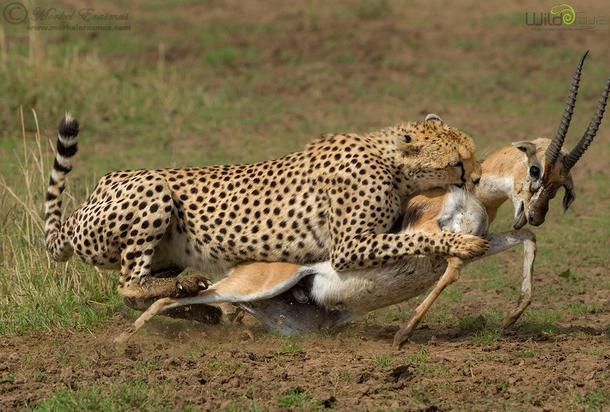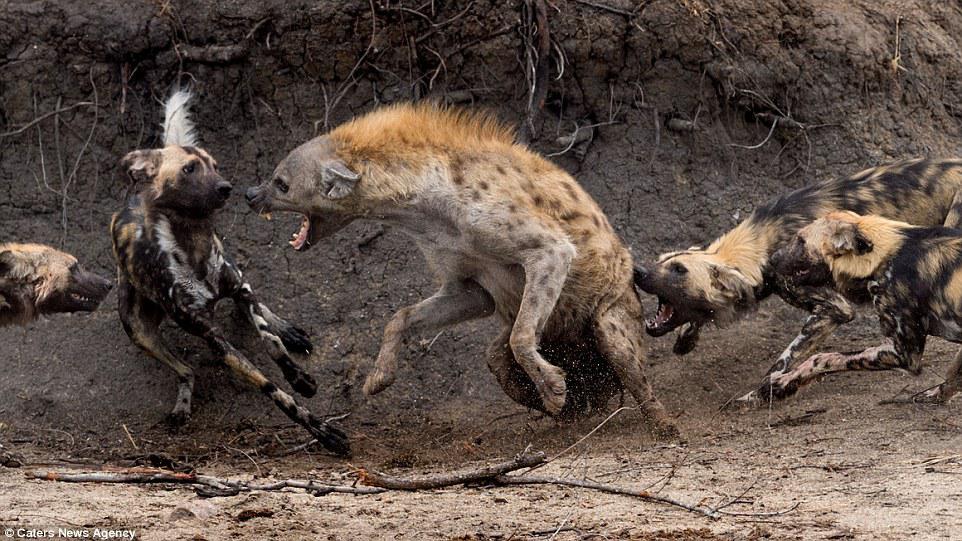The first image is the image on the left, the second image is the image on the right. Evaluate the accuracy of this statement regarding the images: "An antelope is being attacked in the image on the left.". Is it true? Answer yes or no. Yes. The first image is the image on the left, the second image is the image on the right. Evaluate the accuracy of this statement regarding the images: "The right image contains no more than two hyenas.". Is it true? Answer yes or no. No. 